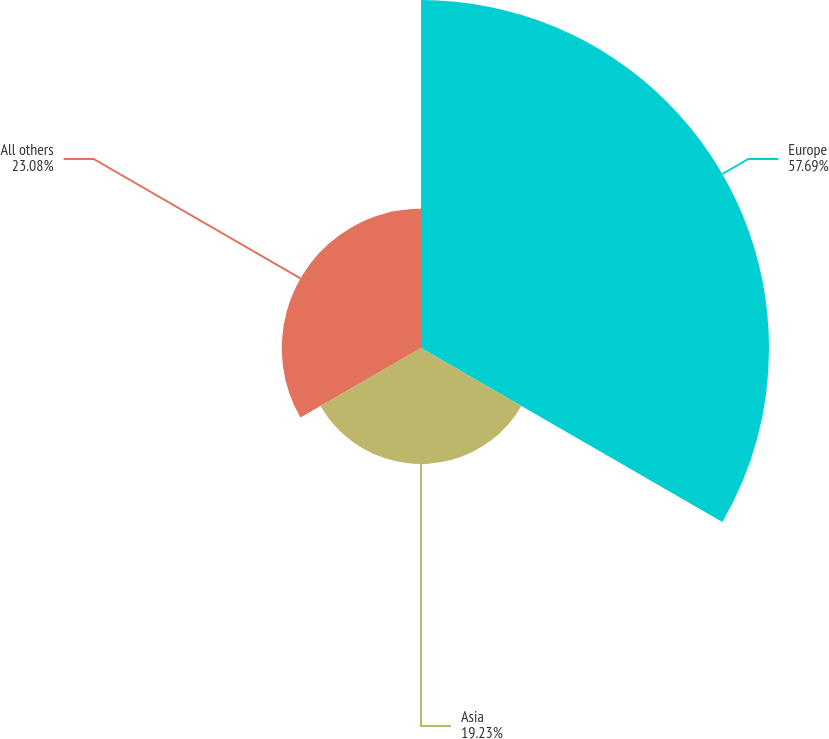Convert chart. <chart><loc_0><loc_0><loc_500><loc_500><pie_chart><fcel>Europe<fcel>Asia<fcel>All others<nl><fcel>57.69%<fcel>19.23%<fcel>23.08%<nl></chart> 